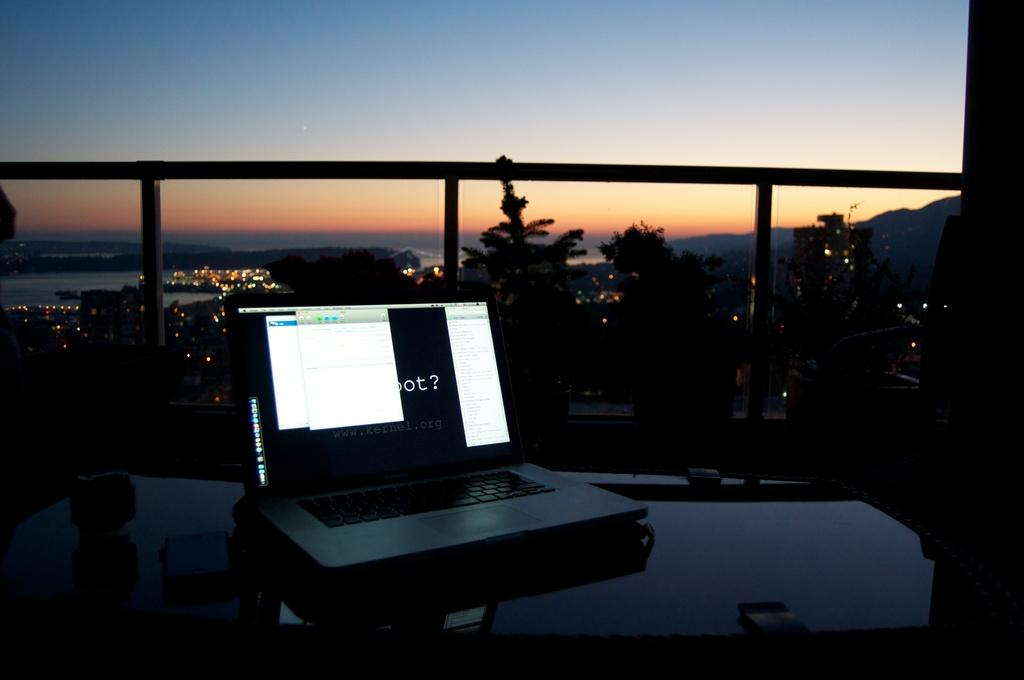<image>
Give a short and clear explanation of the subsequent image. A laptop on a balcony of a tall building has a question mark and the letters O and T on the screen. 